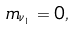<formula> <loc_0><loc_0><loc_500><loc_500>m _ { \nu _ { 1 } } = 0 ,</formula> 